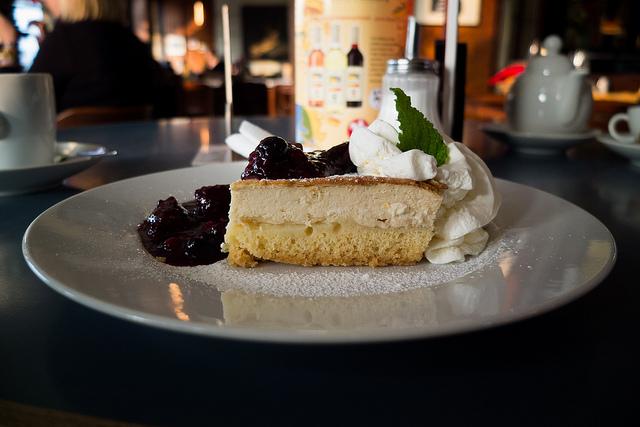What looks like green icing?
Concise answer only. Leaf. How many layers is the cake?
Answer briefly. 2. Is there whipped cream on the dish?
Quick response, please. Yes. What kind of leaf is on the desert?
Short answer required. Mint. Can this food be eaten with a spoon?
Write a very short answer. Yes. What is on the plate?
Be succinct. Cake. 